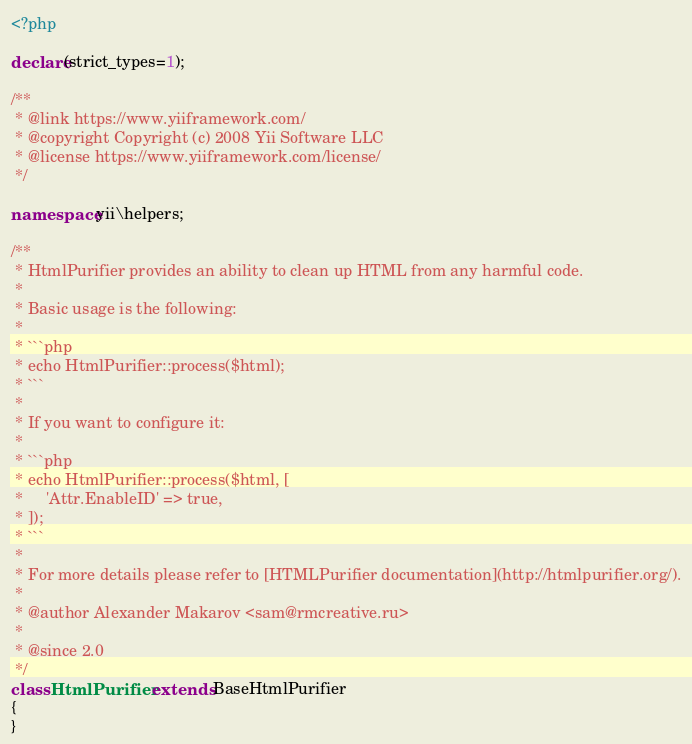Convert code to text. <code><loc_0><loc_0><loc_500><loc_500><_PHP_><?php

declare(strict_types=1);

/**
 * @link https://www.yiiframework.com/
 * @copyright Copyright (c) 2008 Yii Software LLC
 * @license https://www.yiiframework.com/license/
 */

namespace yii\helpers;

/**
 * HtmlPurifier provides an ability to clean up HTML from any harmful code.
 *
 * Basic usage is the following:
 *
 * ```php
 * echo HtmlPurifier::process($html);
 * ```
 *
 * If you want to configure it:
 *
 * ```php
 * echo HtmlPurifier::process($html, [
 *     'Attr.EnableID' => true,
 * ]);
 * ```
 *
 * For more details please refer to [HTMLPurifier documentation](http://htmlpurifier.org/).
 *
 * @author Alexander Makarov <sam@rmcreative.ru>
 *
 * @since 2.0
 */
class HtmlPurifier extends BaseHtmlPurifier
{
}
</code> 